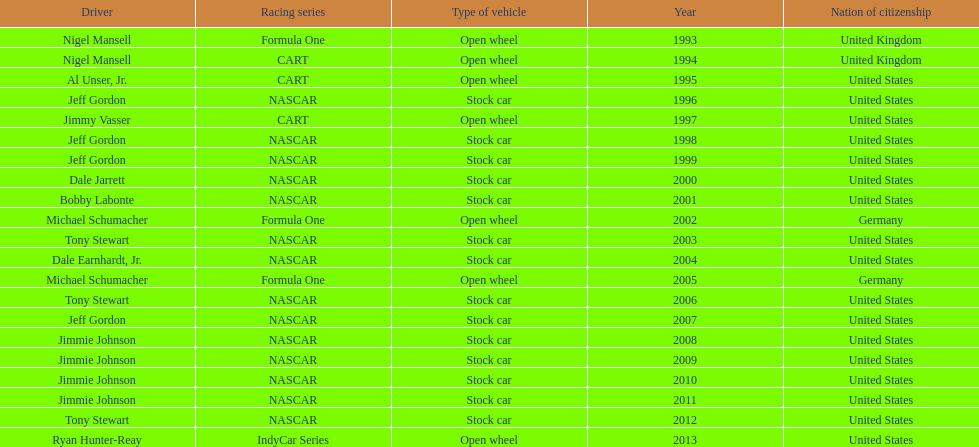Among nigel mansell, al unser jr., michael schumacher, and jeff gordon, only one driver has a single espy award. can you identify who that is? Al Unser, Jr. 